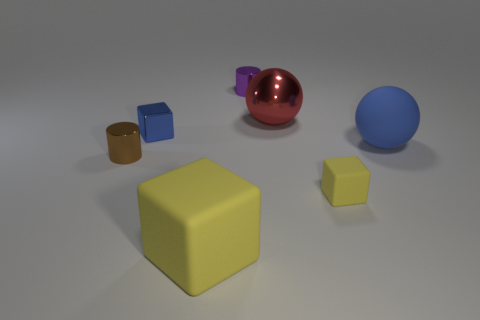Subtract all yellow cylinders. How many yellow cubes are left? 2 Subtract all small cubes. How many cubes are left? 1 Add 2 gray cubes. How many objects exist? 9 Subtract all gray blocks. Subtract all brown balls. How many blocks are left? 3 Subtract all balls. How many objects are left? 5 Add 2 purple matte cubes. How many purple matte cubes exist? 2 Subtract 0 gray spheres. How many objects are left? 7 Subtract all blue balls. Subtract all rubber cubes. How many objects are left? 4 Add 5 blue metal objects. How many blue metal objects are left? 6 